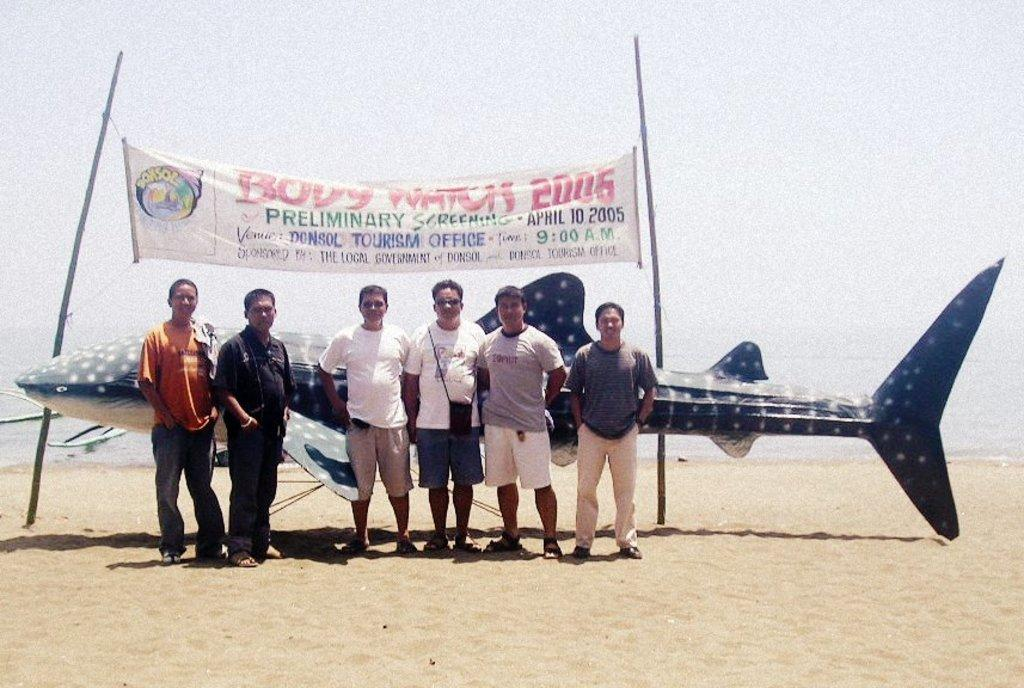<image>
Relay a brief, clear account of the picture shown. Six men on a beach stand in front of a banner for Body Watch 2006 advertising the preliminary screening date for the event. 